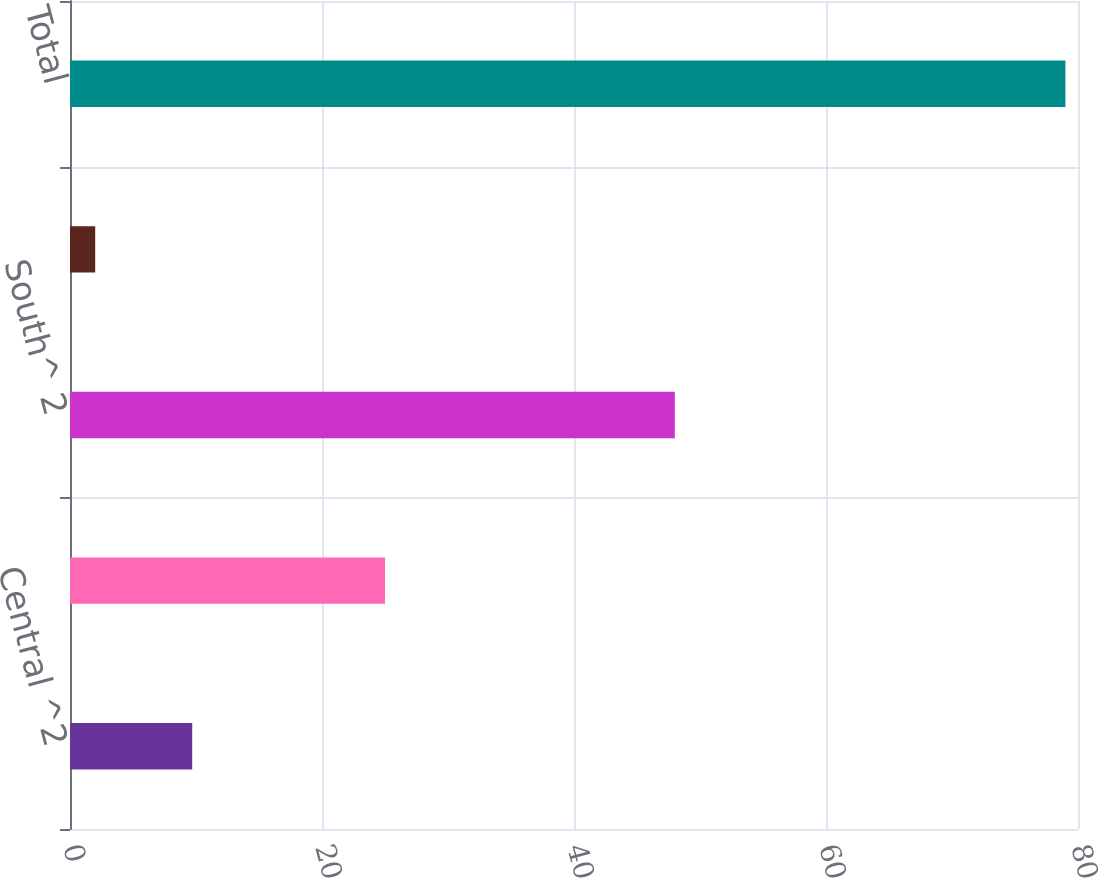Convert chart. <chart><loc_0><loc_0><loc_500><loc_500><bar_chart><fcel>Central ^2<fcel>East ^2 3<fcel>South^ 2<fcel>West ^2<fcel>Total<nl><fcel>9.7<fcel>25<fcel>48<fcel>2<fcel>79<nl></chart> 